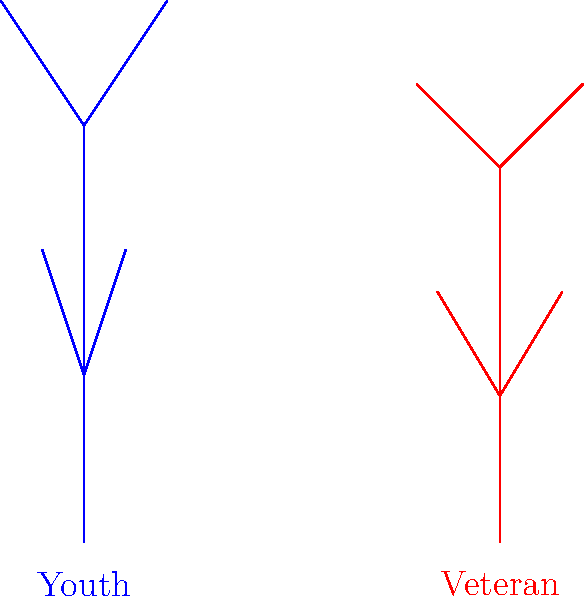Based on the stick figure animations above, which biomechanical aspect is most likely to differ between youth and veteran players during a sprint, and how might this impact their performance? To answer this question, let's analyze the biomechanical differences between youth and veteran players:

1. Stride length: The youth player's legs are more extended, indicating a longer stride. Veteran players often have shorter strides due to reduced flexibility and muscle elasticity.

2. Body posture: The youth player has a more upright posture, while the veteran player is slightly more hunched. This can affect aerodynamics and energy efficiency.

3. Arm swing: The youth player's arms are at a wider angle, potentially generating more momentum. The veteran's arm swing is more compact, which may be more energy-efficient but less powerful.

4. Knee lift: The youth player shows a higher knee lift, which can contribute to a longer stride but may require more energy. The veteran's lower knee lift is more economical but might reduce stride length.

5. Foot placement: While not clearly visible in the animation, foot strike patterns often differ between youth and veteran players, affecting impact forces and energy transfer.

The most significant difference is likely the stride length, as it directly impacts speed and is influenced by flexibility, muscle strength, and joint mobility. Youth players typically have longer strides due to greater flexibility and joint range of motion.

This biomechanical difference impacts performance in several ways:
- Longer strides in youth players can lead to higher top speeds but may require more energy.
- Shorter strides in veteran players might result in lower top speeds but could be more energy-efficient for endurance.
- The difference in stride length affects the player's acceleration and deceleration capabilities.
- It may influence injury risk, with longer strides potentially increasing strain on muscles and joints.

As a coach, understanding these differences is crucial for tailoring training programs and strategies to maximize each player's strengths and mitigate weaknesses based on their age and physical characteristics.
Answer: Stride length; youth longer, veteran shorter, affecting speed and energy efficiency. 